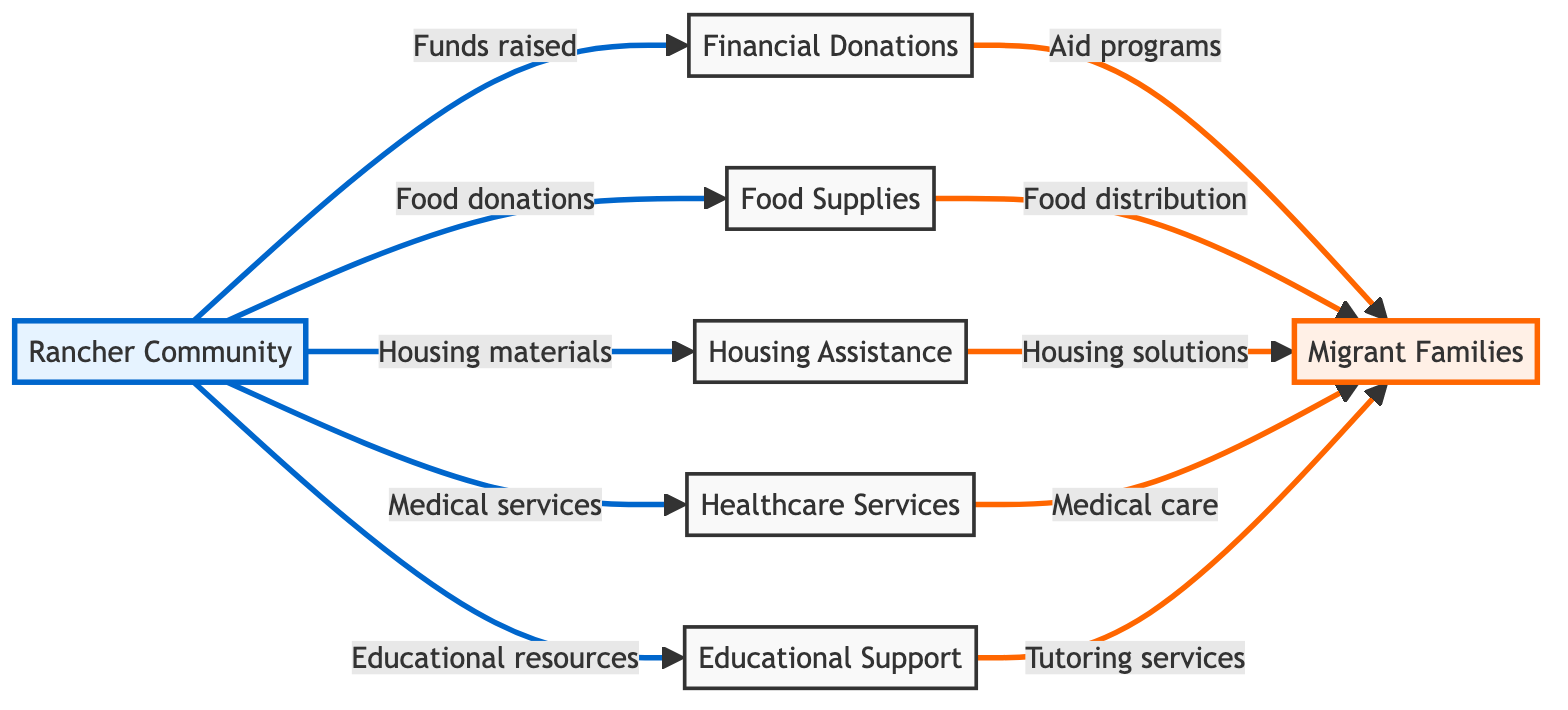What do the rancher communities provide to migrant families? The rancher communities provide five different types of assistance: financial donations, food supplies, housing assistance, healthcare services, and educational support. These are identified by the arrows flowing from the rancher community to the respective nodes.
Answer: Financial donations, food supplies, housing assistance, healthcare services, educational support Which node represents the end recipient of the aid? The end recipient of the aid is represented by the node "Migrant Families." This is the target node where all the flows of resources converge.
Answer: Migrant Families How many types of aid flow from the rancher community to the migrant families? There are five distinct types of aid flowing from the rancher community to the migrant families as indicated by the five arrows pointing to the migrant families node.
Answer: Five What type of assistance includes medical services? Medical services fall under the "Healthcare Services" category, which is one of the types of assistance provided by the rancher community to migrant families. This is derived from following the flow from the rancher community to healthcare services and then to migrant families.
Answer: Healthcare Services What is the relationship between food donations and migrant families? The relationship is that food donations from the rancher community lead to food distribution for migrant families. This connection is shown by the arrow flowing from food supplies to migrant families.
Answer: Food distribution Which assistance category has the direct connection to housing solutions for migrant families? "Housing Assistance" is the assistance category that provides a direct connection to housing solutions for migrant families, as illustrated by the arrow linking housing assistance to migrant families.
Answer: Housing Assistance What is the role of financial donations in the context of the diagram? Financial donations serve as a means of funding various aid programs for migrant families. This is identified by the arrow connecting financial donations to migrant families.
Answer: Aid programs Which flow represents educational resources provided by the rancher community? The flow that represents educational resources is from "Educational Support" to "Migrant Families," indicating that educational resources go to support the migrant families.
Answer: Educational Support 